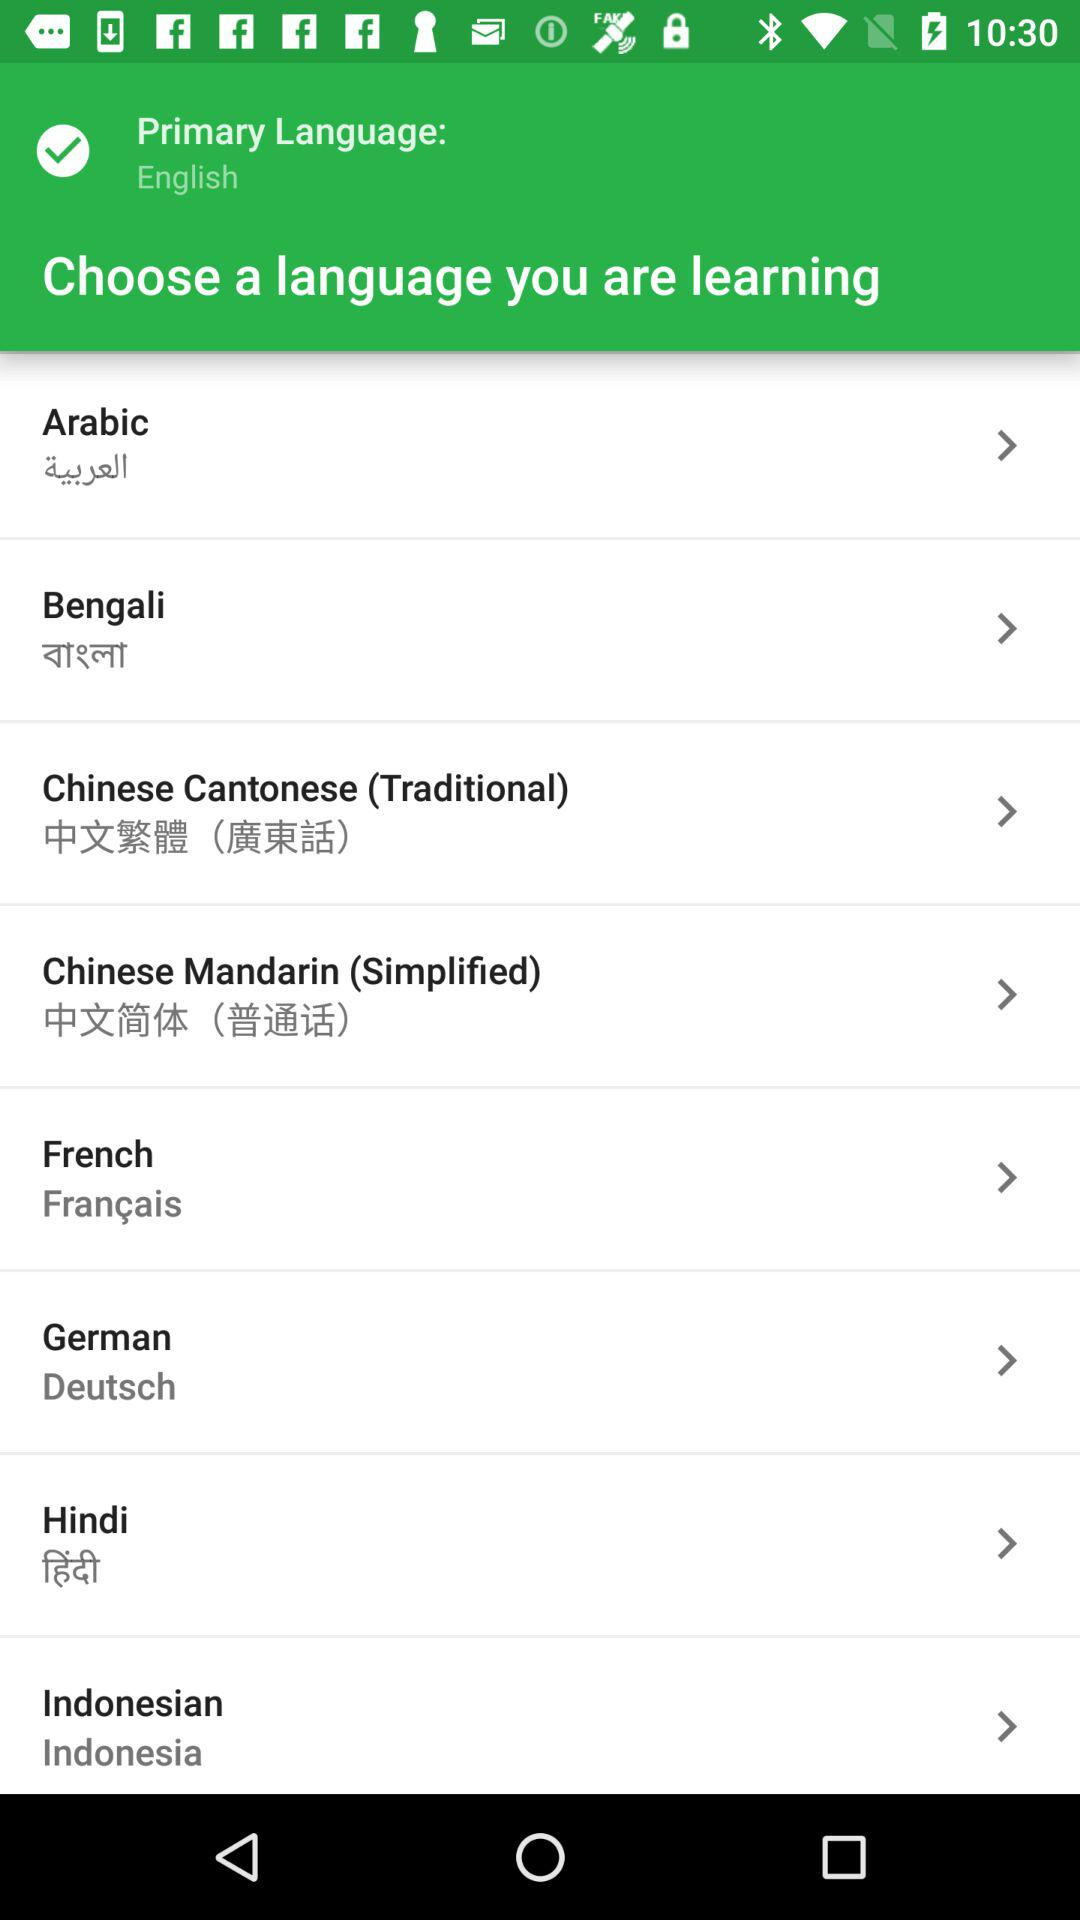How many languages are available to learn?
Answer the question using a single word or phrase. 8 